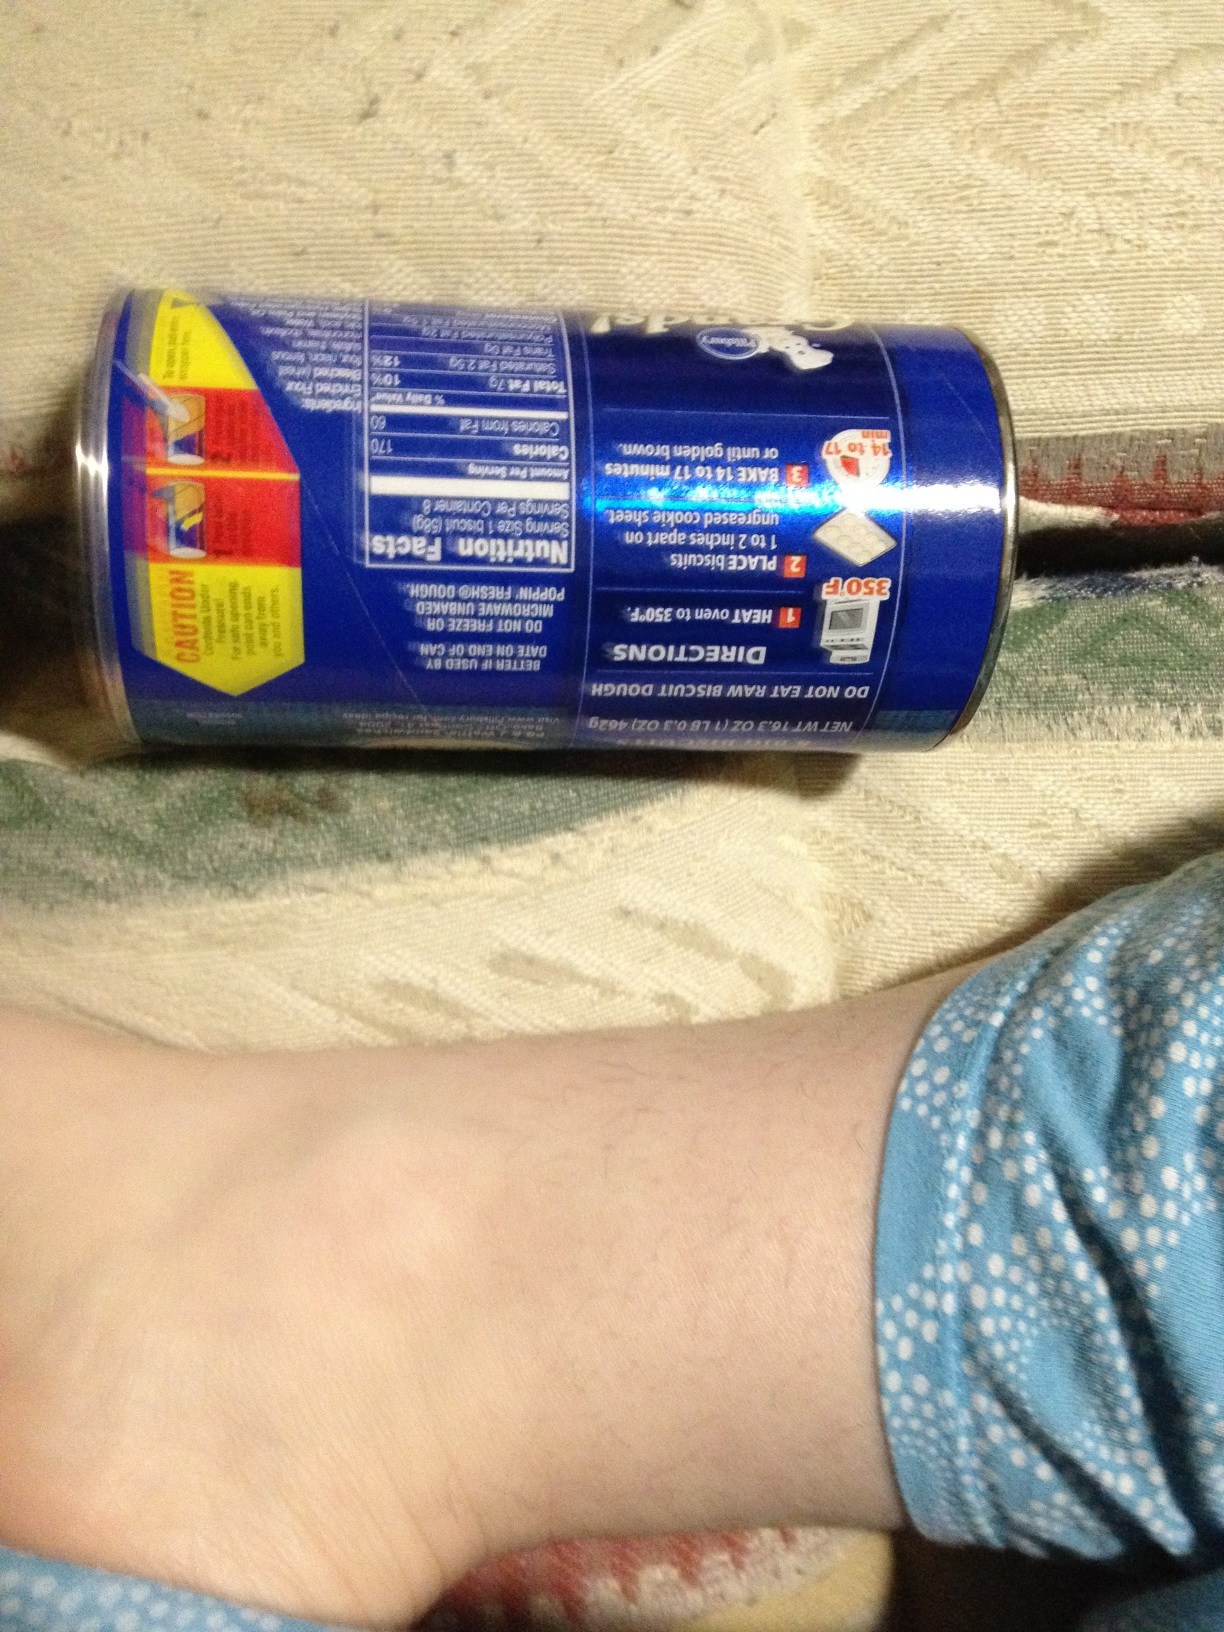Are there any specific dietary precautions mentioned on this can of biscuits? Yes, the can has a caution label stating: 'Do not eat raw biscuit dough. Keep refrigerated.' It also provides allergens information: 'Contains wheat and may contain traces of milk and soy.' 